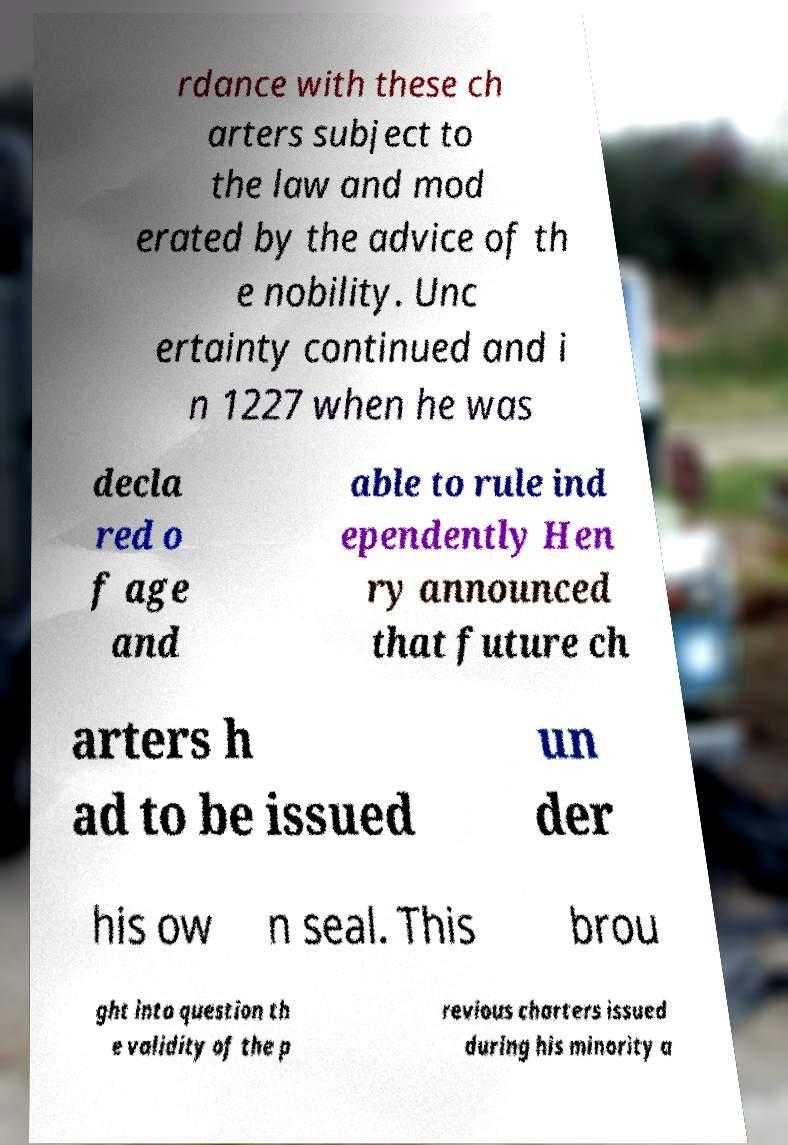For documentation purposes, I need the text within this image transcribed. Could you provide that? rdance with these ch arters subject to the law and mod erated by the advice of th e nobility. Unc ertainty continued and i n 1227 when he was decla red o f age and able to rule ind ependently Hen ry announced that future ch arters h ad to be issued un der his ow n seal. This brou ght into question th e validity of the p revious charters issued during his minority a 